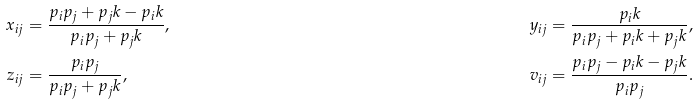<formula> <loc_0><loc_0><loc_500><loc_500>x _ { i j } & = \frac { p _ { i } p _ { j } + p _ { j } k - p _ { i } k } { p _ { i } p _ { j } + p _ { j } k } , & y _ { i j } = \frac { p _ { i } k } { p _ { i } p _ { j } + p _ { i } k + p _ { j } k } , \\ z _ { i j } & = \frac { p _ { i } p _ { j } } { p _ { i } p _ { j } + p _ { j } k } , & v _ { i j } = \frac { p _ { i } p _ { j } - p _ { i } k - p _ { j } k } { p _ { i } p _ { j } } .</formula> 